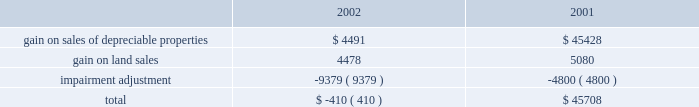Management 2019s discussion and analysis of financial conditionand results of operations d u k e r e a l t y c o r p o r a t i o n 1 1 2 0 0 2 a n n u a l r e p o r t 2022 interest expense on the company 2019s secured debt decreased from $ 30.8 million in 2001 to $ 22.9 million in 2002 as the company paid off $ 13.5 million of secured debt throughout 2002 and experienced lower borrowings on its secured line of credit during 2002 compared to 2001 .
Additionally , the company paid off approximately $ 128.5 million of secured debt throughout 2001 .
2022 interest expense on the company 2019s $ 500 million unsecured line of credit decreased by approximately $ 1.1 million in 2002 compared to 2001 as the company maintained lower balances on the line throughout most of 2002 .
As a result of the above-mentioned items , earnings from rental operations decreased $ 35.0 million from $ 254.1 million for the year ended december 31 , 2001 , to $ 219.1 million for the year ended december 31 , 2002 .
Service operations service operations primarily consist of leasing , management , construction and development services for joint venture properties and properties owned by third parties .
Service operations revenues decreased from $ 80.5 million for the year ended december 31 , 2001 , to $ 68.6 million for the year ended december 31 , 2002 .
The prolonged effect of the slow economy has been the primary factor in the overall decrease in revenues .
The company experienced a decrease of $ 12.7 million in net general contractor revenues because of a decrease in the volume of construction in 2002 , compared to 2001 , as well as slightly lower profit margins .
Property management , maintenance and leasing fee revenues decreased from $ 22.8 million in 2001 to $ 14.3 million in 2002 primarily because of a decrease in landscaping maintenance revenue resulting from the sale of the landscaping operations in the third quarter of 2001 .
Construction management and development activity income represents construction and development fees earned on projects where the company acts as the construction manager along with profits from the company 2019s held for sale program whereby the company develops a property for sale upon completion .
The increase in revenues of $ 10.3 million in 2002 is primarily due to an increase in volume of the sale of properties from the held for sale program .
Service operations expenses decreased from $ 45.3 million in 2001 to $ 38.3 million in 2002 .
The decrease is attributable to the decrease in construction and development activity and the reduced overhead costs as a result of the sale of the landscape business in 2001 .
As a result of the above , earnings from service operations decreased from $ 35.1 million for the year ended december 31 , 2001 , to $ 30.3 million for the year ended december 31 , 2002 .
General and administrative expense general and administrative expense increased from $ 15.6 million in 2001 to $ 25.4 million for the year ended december 31 , 2002 .
The company has been successful reducing total operating and administration costs ; however , reduced construction and development activities have resulted in a greater amount of overhead being charged to general and administrative expense instead of being capitalized into development projects or charged to service operations .
Other income and expenses gain on sale of land and depreciable property dispositions , net of impairment adjustment , is comprised of the following amounts in 2002 and 2001 : gain on sales of depreciable properties represent sales of previously held for investment rental properties .
Beginning in 2000 and continuing into 2001 , the company pursued favorable opportunities to dispose of real estate assets that no longer met long-term investment objectives .
In 2002 , the company significantly reduced this property sales program until the business climate improves and provides better investment opportunities for the sale proceeds .
Gain on land sales represents sales of undeveloped land owned by the company .
The company pursues opportunities to dispose of land in markets with a high concentration of undeveloped land and those markets where the land no longer meets strategic development plans of the company .
The company recorded a $ 9.4 million adjustment in 2002 associated with six properties determined to have an impairment of book value .
The company has analyzed each of its in-service properties and has determined that there are no additional valuation adjustments that need to be made as of december 31 , 2002 .
The company recorded an adjustment of $ 4.8 million in 2001 for one property that the company had contracted to sell for a price less than its book value .
Other revenue for the year ended december 31 , 2002 , includes $ 1.4 million of gain related to an interest rate swap that did not qualify for hedge accounting. .

What is the percent change in gain on land sales from 2001 to 2002? 
Rationale: unable to synthesize table and text because it is unclear whether the table is in thousands or millions .
Computations: (((4478 - 5080) / 5080) * 100)
Answer: -11.85039. 